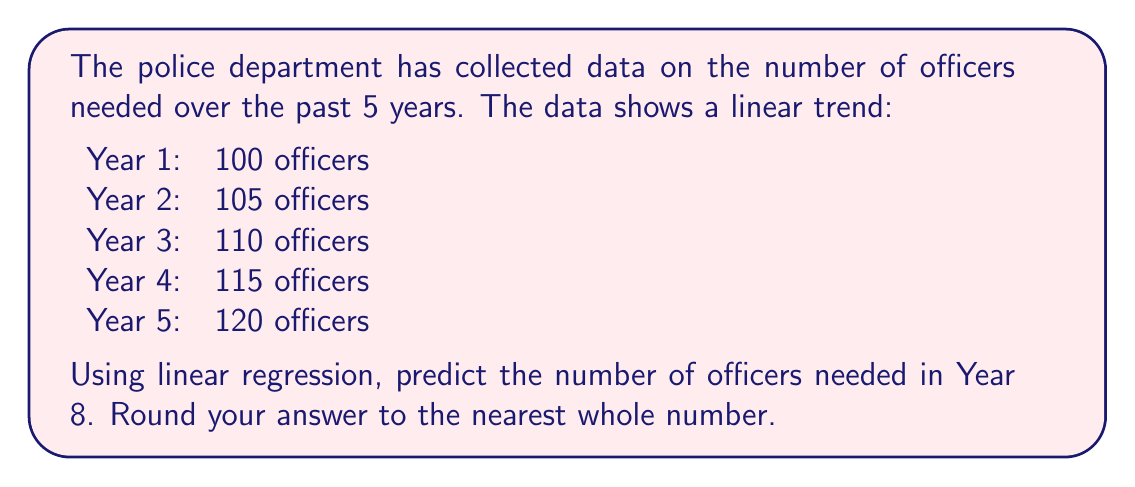Give your solution to this math problem. To solve this problem, we'll use linear regression to find the line of best fit and then use it to predict the number of officers needed in Year 8.

1. Let's define our variables:
   $x$: year (1, 2, 3, 4, 5)
   $y$: number of officers (100, 105, 110, 115, 120)

2. We need to calculate the following:
   $n$ = number of data points = 5
   $\sum x$ = 1 + 2 + 3 + 4 + 5 = 15
   $\sum y$ = 100 + 105 + 110 + 115 + 120 = 550
   $\sum xy$ = 1(100) + 2(105) + 3(110) + 4(115) + 5(120) = 1650
   $\sum x^2$ = 1² + 2² + 3² + 4² + 5² = 55

3. The linear regression equation is $y = mx + b$, where:

   $m = \frac{n\sum xy - \sum x \sum y}{n\sum x^2 - (\sum x)^2}$

   $b = \frac{\sum y - m\sum x}{n}$

4. Let's calculate $m$:

   $m = \frac{5(1650) - 15(550)}{5(55) - 15^2} = \frac{8250 - 8250}{275 - 225} = \frac{0}{50} = 5$

5. Now, let's calculate $b$:

   $b = \frac{550 - 5(15)}{5} = \frac{550 - 75}{5} = 95$

6. Our linear regression equation is:

   $y = 5x + 95$

7. To predict the number of officers in Year 8, we substitute $x = 8$:

   $y = 5(8) + 95 = 40 + 95 = 135$

Therefore, the predicted number of officers needed in Year 8 is 135.
Answer: 135 officers 